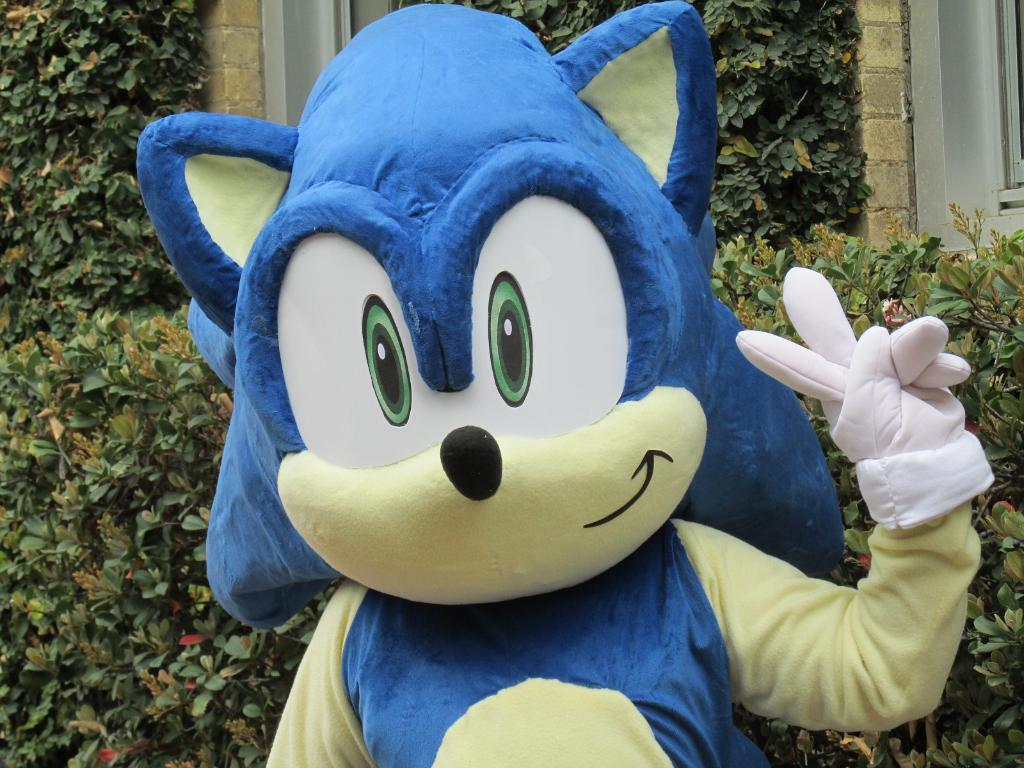What is the person in the image wearing? The person is wearing a cartoon costume in the image. What can be seen in the background of the image? Plants and trees are visible in the background of the image. What date is marked on the calendar in the image? There is no calendar present in the image. What time of day is depicted in the image? The time of day is not specified in the image. 